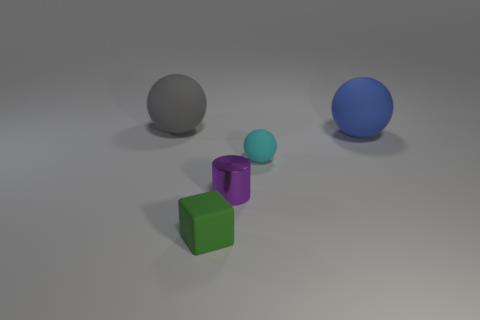Subtract all large rubber spheres. How many spheres are left? 1 Add 4 blue matte things. How many objects exist? 9 Subtract all blocks. How many objects are left? 4 Subtract 0 yellow cylinders. How many objects are left? 5 Subtract all tiny cyan matte cylinders. Subtract all large blue rubber spheres. How many objects are left? 4 Add 5 tiny cyan rubber balls. How many tiny cyan rubber balls are left? 6 Add 3 tiny yellow objects. How many tiny yellow objects exist? 3 